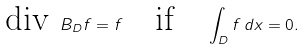<formula> <loc_0><loc_0><loc_500><loc_500>\text {div } B _ { D } f = f \quad \text {if} \quad \int _ { D } f \, d x = 0 .</formula> 